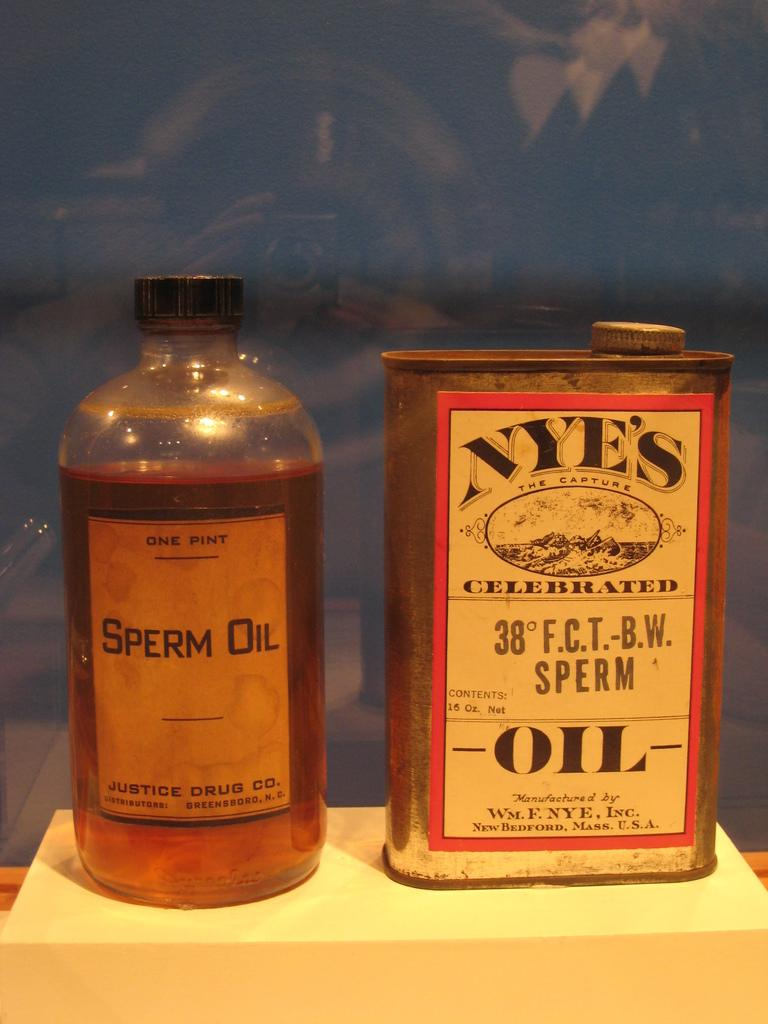What type of container is visible in the image? There is a glass bottle in the image. What is inside the glass bottle? The glass bottle contains some liquid. What other object can be seen on the table in the image? There is a metal box on the table. Where are the glass bottle and metal box located in the image? Both the glass bottle and metal box are on a table. What type of insect is crawling on the dad's shoulder in the image? There is no dad or insect present in the image. 